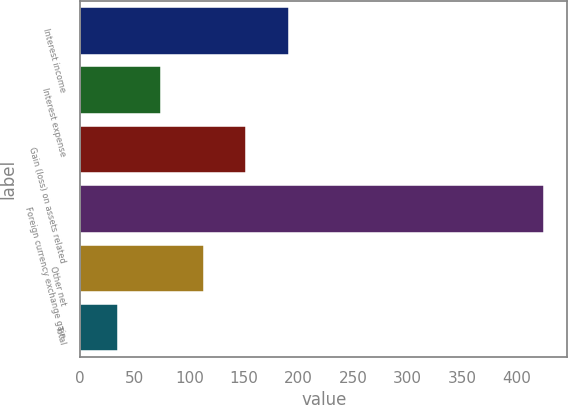Convert chart to OTSL. <chart><loc_0><loc_0><loc_500><loc_500><bar_chart><fcel>Interest income<fcel>Interest expense<fcel>Gain (loss) on assets related<fcel>Foreign currency exchange gain<fcel>Other net<fcel>Total<nl><fcel>191<fcel>74<fcel>152<fcel>425<fcel>113<fcel>35<nl></chart> 